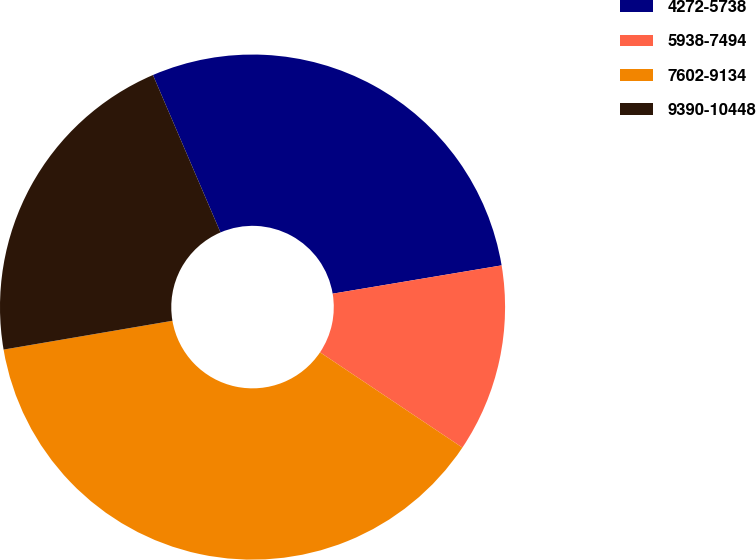<chart> <loc_0><loc_0><loc_500><loc_500><pie_chart><fcel>4272-5738<fcel>5938-7494<fcel>7602-9134<fcel>9390-10448<nl><fcel>28.81%<fcel>12.03%<fcel>37.92%<fcel>21.24%<nl></chart> 